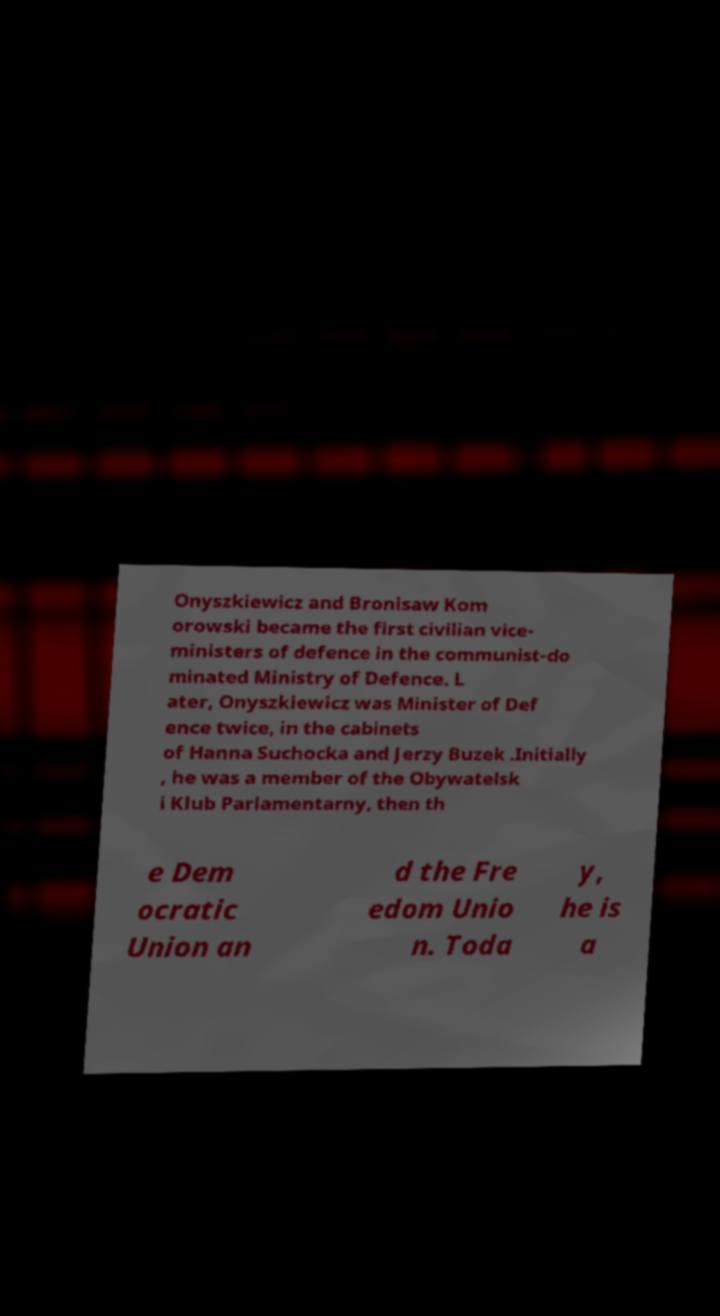Please identify and transcribe the text found in this image. Onyszkiewicz and Bronisaw Kom orowski became the first civilian vice- ministers of defence in the communist-do minated Ministry of Defence. L ater, Onyszkiewicz was Minister of Def ence twice, in the cabinets of Hanna Suchocka and Jerzy Buzek .Initially , he was a member of the Obywatelsk i Klub Parlamentarny, then th e Dem ocratic Union an d the Fre edom Unio n. Toda y, he is a 